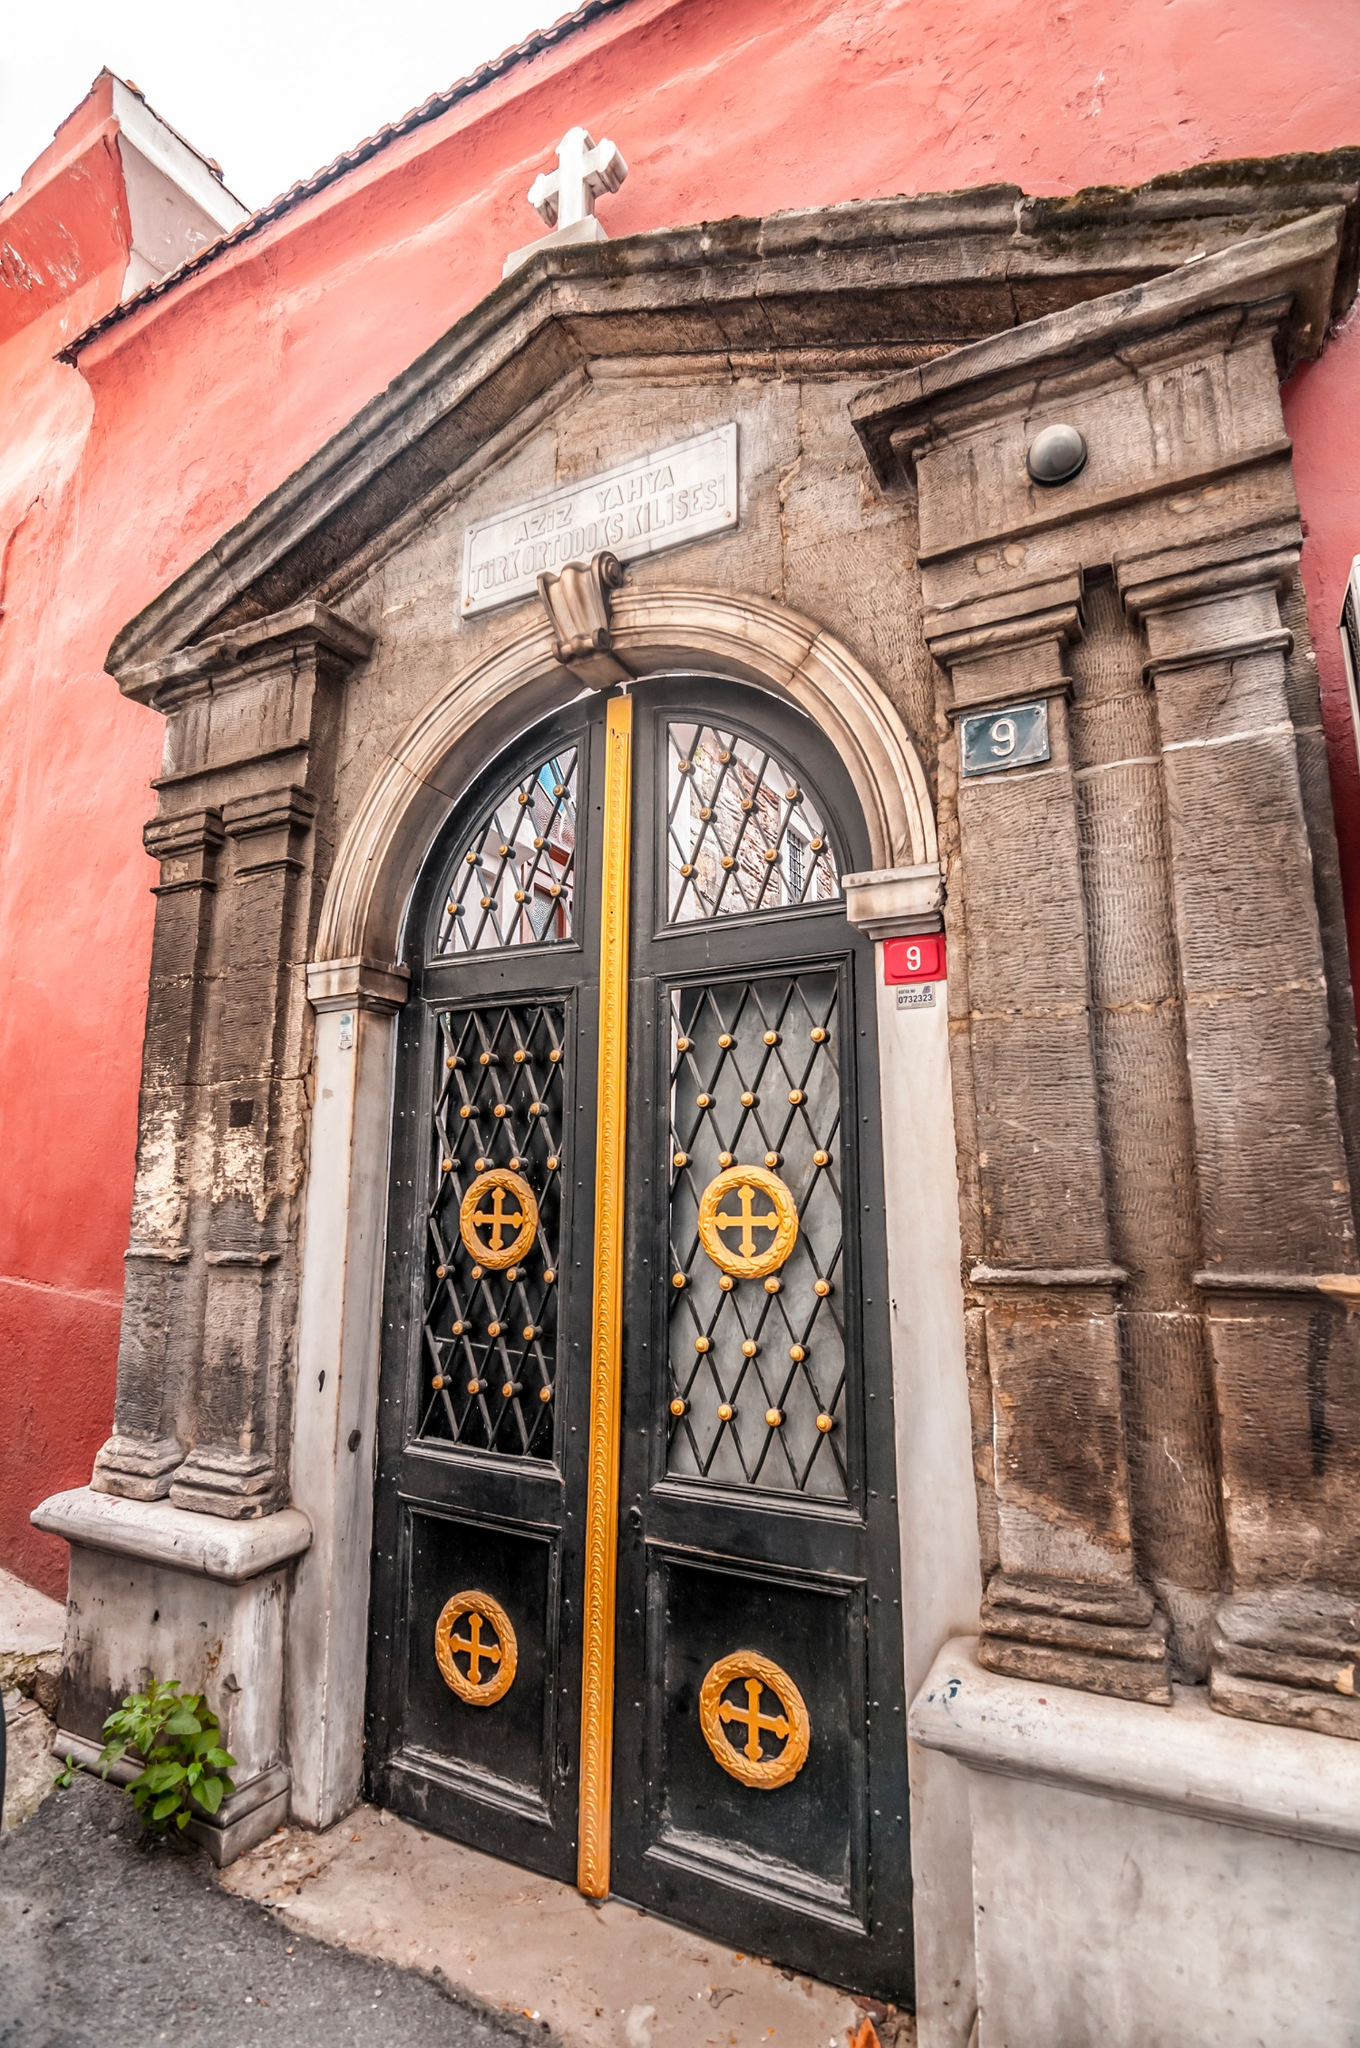Describe a realistic scenario that this building might witness daily. Every morning, as the first light of dawn hits the red walls of the building, the black metal door creaks open. A caretaker steps out to sweep the steps and light incense, preparing the space for the day’s visitors. Throughout the day, parishioners come and go, some entering for a moment of quiet prayer, others stopping to light a candle for a loved one. The building witnesses the daily rhythm of life - a mix of devotion, reflection, and community interaction. Children play on the street, their laughter echoing against the ancient stones, while elderly members of the community sit on the steps, sharing stories of days gone by. 